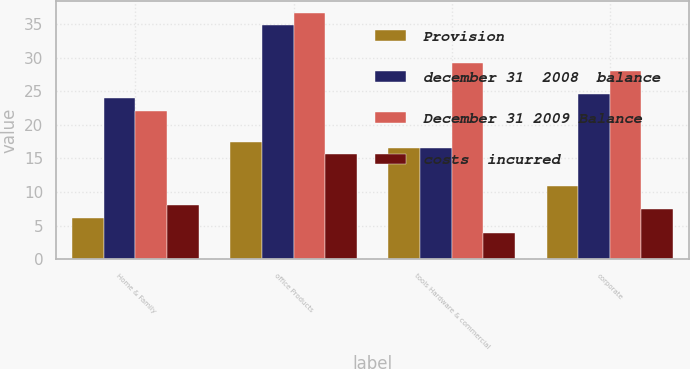Convert chart. <chart><loc_0><loc_0><loc_500><loc_500><stacked_bar_chart><ecel><fcel>Home & Family<fcel>office Products<fcel>tools Hardware & commercial<fcel>corporate<nl><fcel>Provision<fcel>6.1<fcel>17.5<fcel>16.5<fcel>10.9<nl><fcel>december 31  2008  balance<fcel>24<fcel>34.8<fcel>16.6<fcel>24.6<nl><fcel>December 31 2009 Balance<fcel>22.1<fcel>36.6<fcel>29.2<fcel>28<nl><fcel>costs  incurred<fcel>8<fcel>15.7<fcel>3.9<fcel>7.5<nl></chart> 